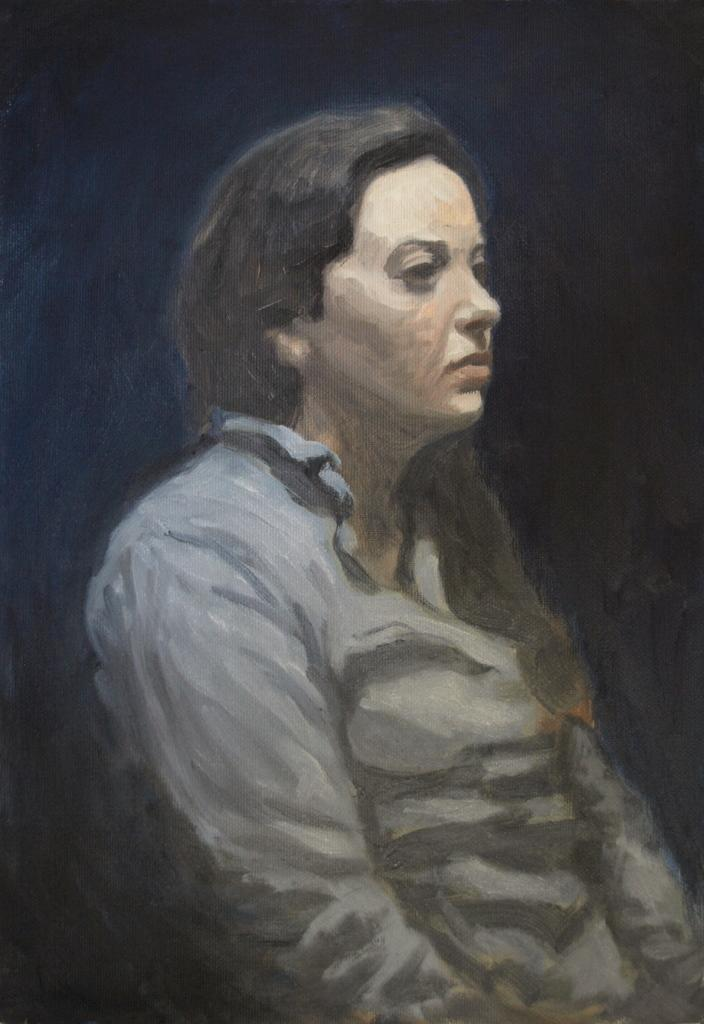What type of artwork is the image? The image is a painted picture. What is the main subject in the foreground of the image? There is a woman in the foreground of the image. How would you describe the background of the image? The background of the image is dark. Can you see any mountains in the background of the image? There are no mountains visible in the image; the background is dark. Is the woman wearing a mask in the image? There is no mention of a mask in the image, and it cannot be determined from the provided facts. 